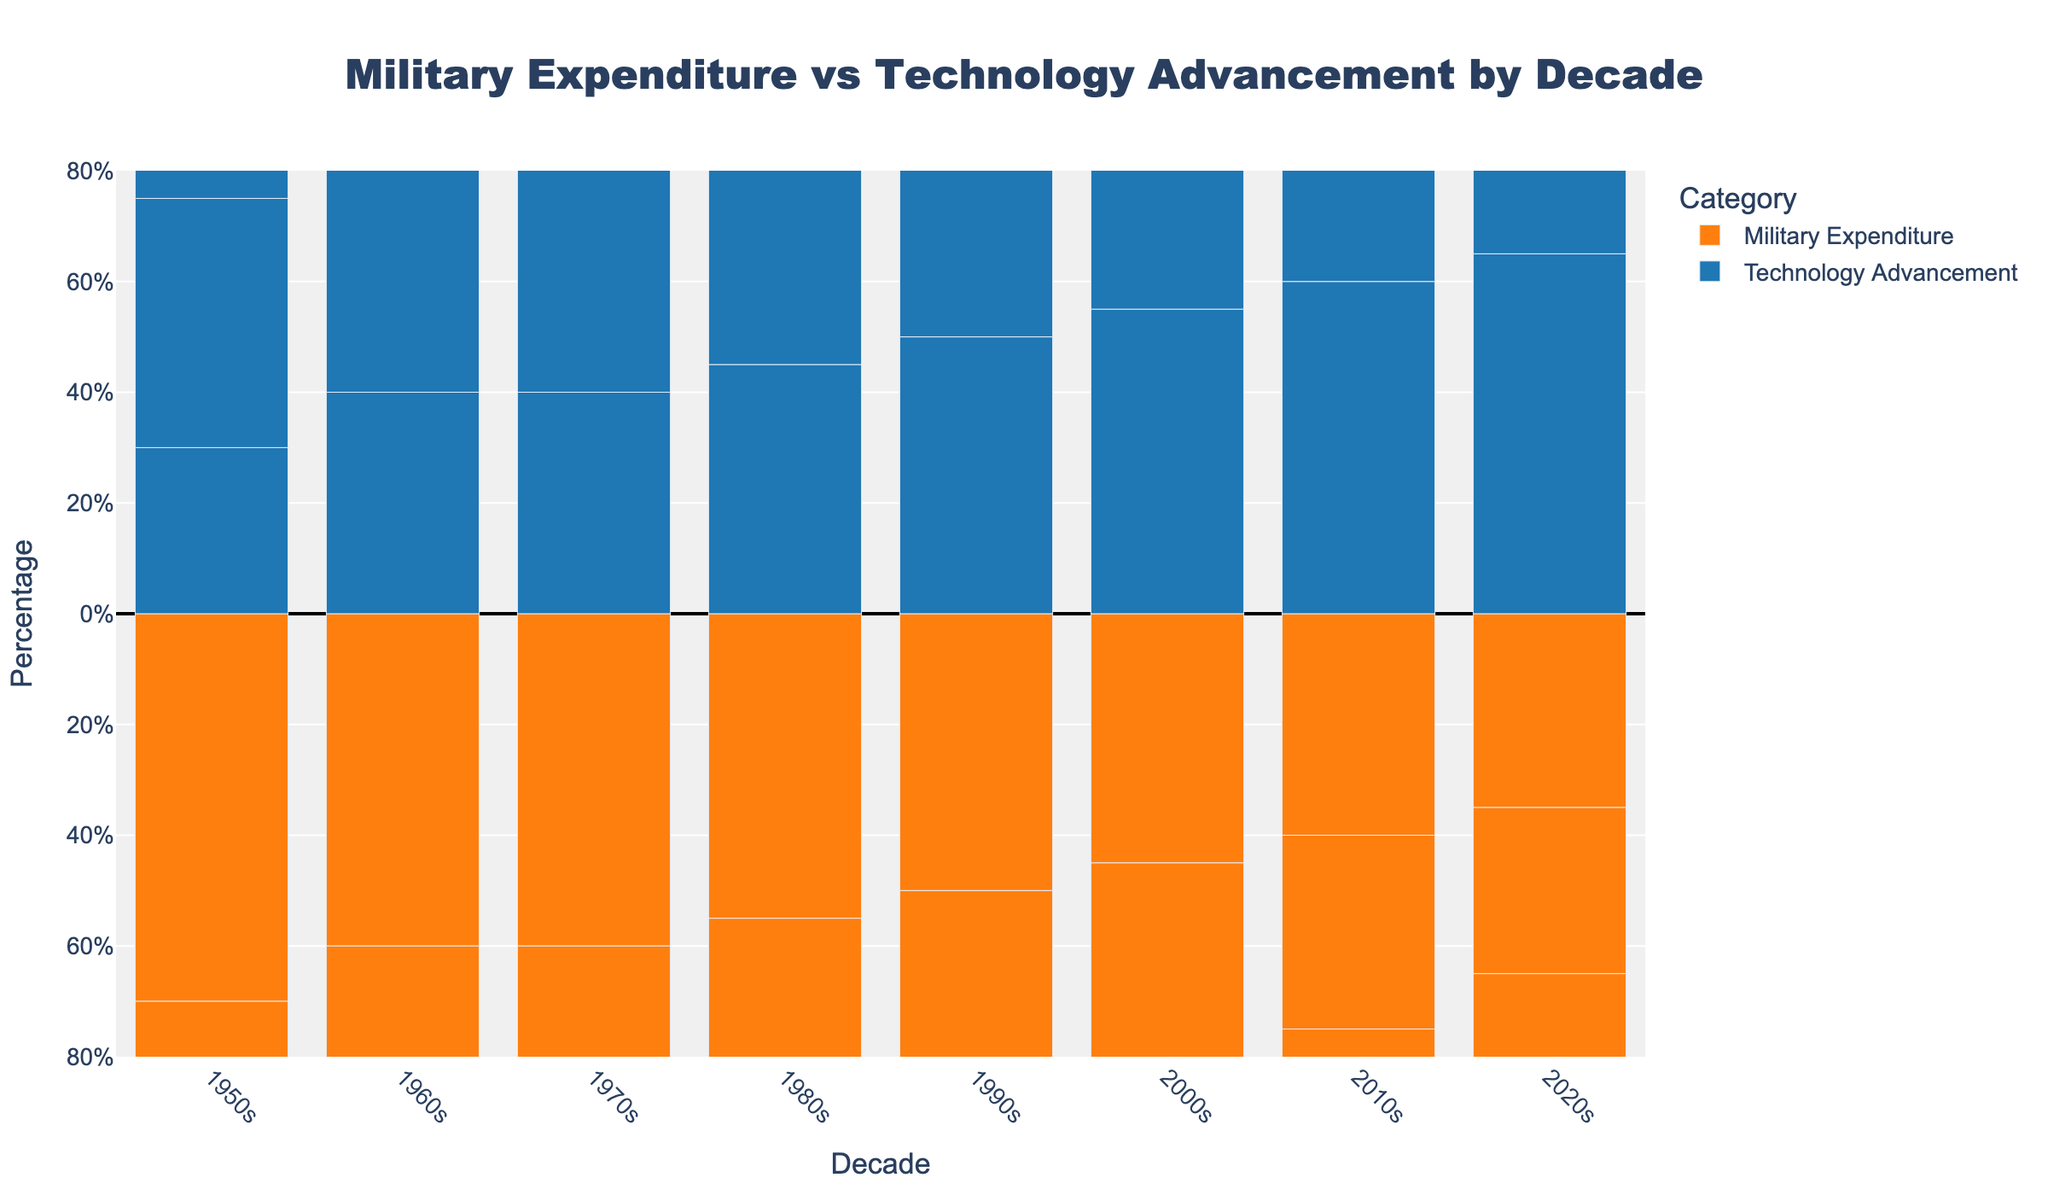What trend can be observed in the United States' military expenditure from the 1950s to the 2020s? Examine the heights of the orange bars representing the United States across each decade. The bars decrease in height over time, indicating a reduction in military expenditure percentages.
Answer: Military expenditure decreases By the 2020s, which country has the lowest military expenditure percentage and what is it? Look for the shortest orange bar in the 2020s. The United States has the shortest bar, indicating the lowest military expenditure percentage.
Answer: United States, 20% In which decade does Russia show a difference in percentage between military expenditure and technology advancement, and what is the difference? Identify the respective heights of the orange and blue bars for Russia across the decades and calculate the differences. In the 2000s, the difference is maximum with military expenditure at 40% and technology advancement at 60%, resulting in a difference of 20%.
Answer: 2000s, 20% How does China's investment in technology advancement in the 2010s compare to the United Kingdom's in the 1950s? Compare the height of the blue bar for China in the 2010s to the blue bar for the United Kingdom in the 1950s. Both bars are equal in height at 60% for China and 45% for the United Kingdom.
Answer: China invests more, 60% vs 45% Which decade saw the biggest change in the United States' technology advancement percentage from the previous decade and what is the change? Identify the heights of the blue bars for the United States and note the changes between decades. The most significant change is between the 1990s and 2000s, where it increased from 65% to 70%, a change of 5%.
Answer: 2000s-1990s, 5% From the 1950s to the 2020s, which country shifted focus the most drastically from military expenditure to technology advancement? Calculate the difference in the heights of the orange and blue bars for each country in the 1950s and 2020s, then find the largest change in percentage. The United States shows the most drastic shift from 65% military expenditure in the 1950s to 20% in the 2020s and 35% to 80% in technology advancement, a total shift of 95%.
Answer: United States 